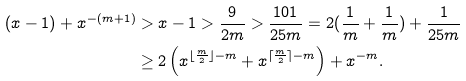Convert formula to latex. <formula><loc_0><loc_0><loc_500><loc_500>( x - 1 ) + x ^ { - ( m + 1 ) } & > x - 1 > \frac { 9 } { 2 m } > \frac { 1 0 1 } { 2 5 m } = 2 ( \frac { 1 } { m } + \frac { 1 } { m } ) + \frac { 1 } { 2 5 m } \\ & \geq 2 \left ( x ^ { \lfloor \frac { m } { 2 } \rfloor - m } + x ^ { \lceil \frac { m } { 2 } \rceil - m } \right ) + x ^ { - m } .</formula> 